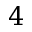<formula> <loc_0><loc_0><loc_500><loc_500>4</formula> 